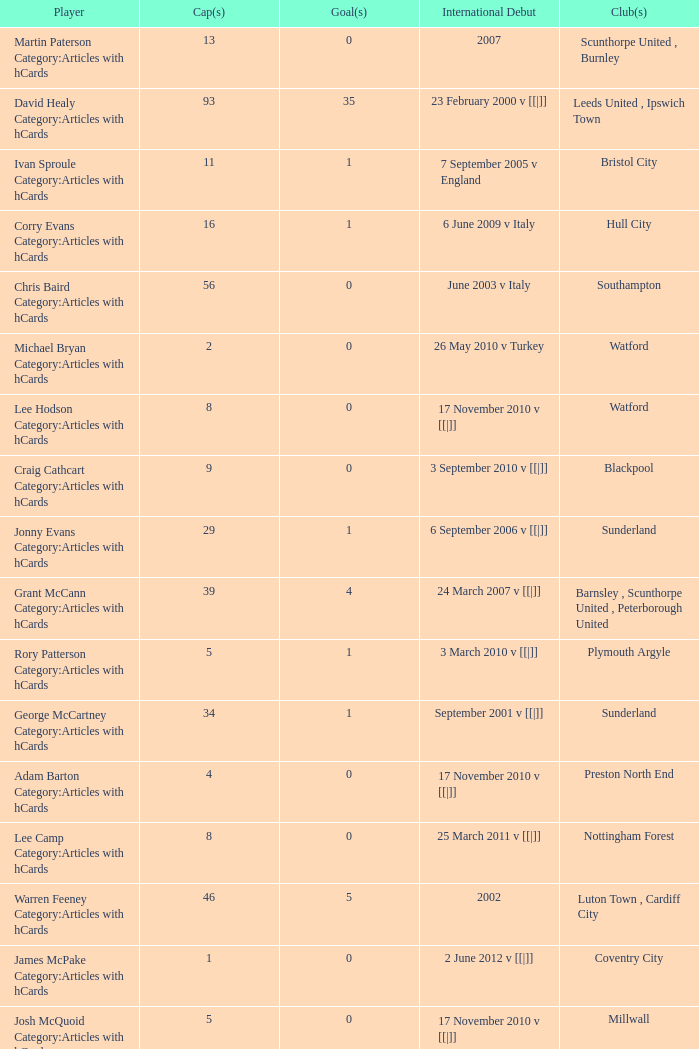How many caps figures are there for Norwich City, Coventry City? 1.0. 